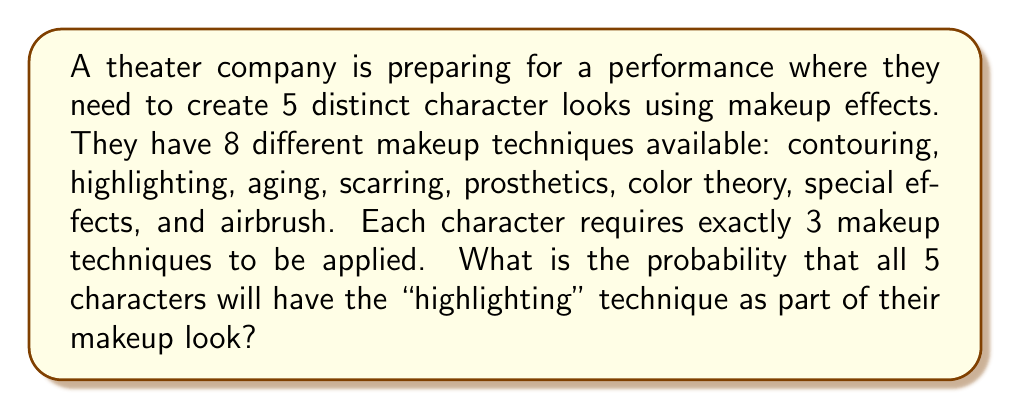Help me with this question. Let's approach this step-by-step:

1) First, we need to calculate the total number of ways to choose 3 techniques out of 8 for each character. This is a combination problem, represented as $\binom{8}{3}$.

   $\binom{8}{3} = \frac{8!}{3!(8-3)!} = \frac{8!}{3!5!} = 56$

2) Now, for the characters that include highlighting, we need to choose 2 more techniques out of the remaining 7. This is represented as $\binom{7}{2}$.

   $\binom{7}{2} = \frac{7!}{2!(7-2)!} = \frac{7!}{2!5!} = 21$

3) The probability of a single character having highlighting in their makeup is:

   $P(\text{highlighting}) = \frac{21}{56} = \frac{3}{8}$

4) We want all 5 characters to have highlighting. Since the makeup for each character is chosen independently, we multiply these probabilities:

   $P(\text{all 5 have highlighting}) = (\frac{3}{8})^5$

5) Calculating this:

   $(\frac{3}{8})^5 = \frac{243}{32768} \approx 0.00741$

Therefore, the probability that all 5 characters will have the "highlighting" technique as part of their makeup look is $\frac{243}{32768}$ or approximately 0.741%.
Answer: $\frac{243}{32768}$ or approximately 0.00741 (0.741%) 